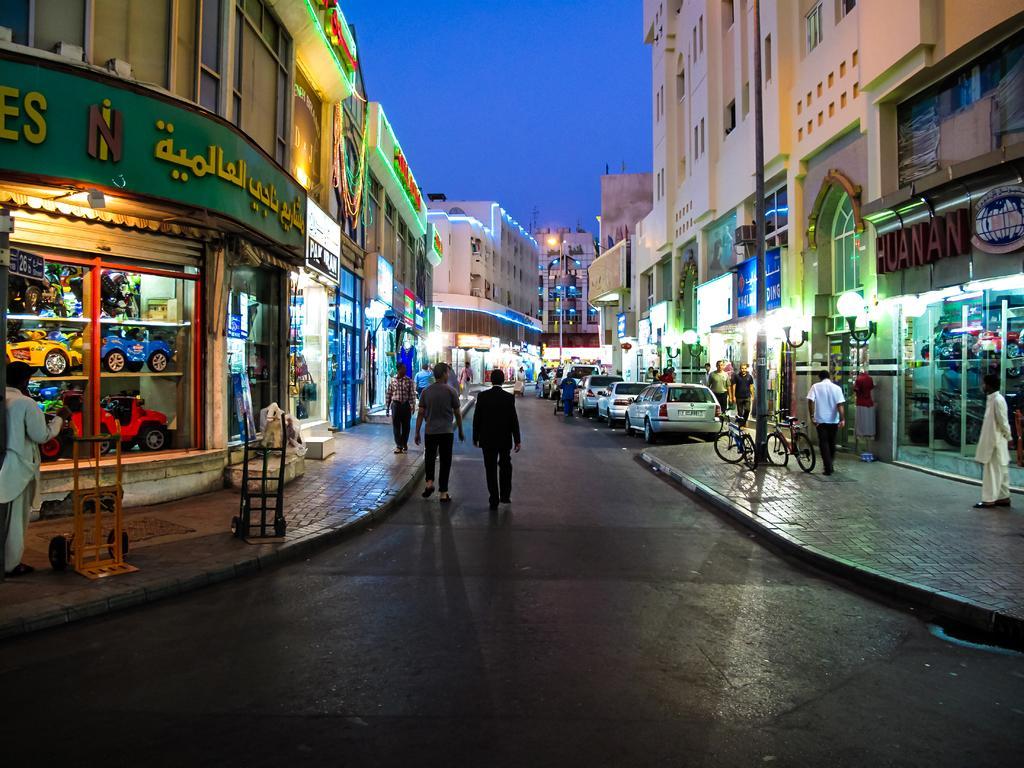Please provide a concise description of this image. In the image I can see people are walking on the ground. I can also see buildings, boards, bicycles, lights on walls of a buildings, toys in a shop, poles and some other objects on the ground. In the background I can see vehicles on the road and the sky. 